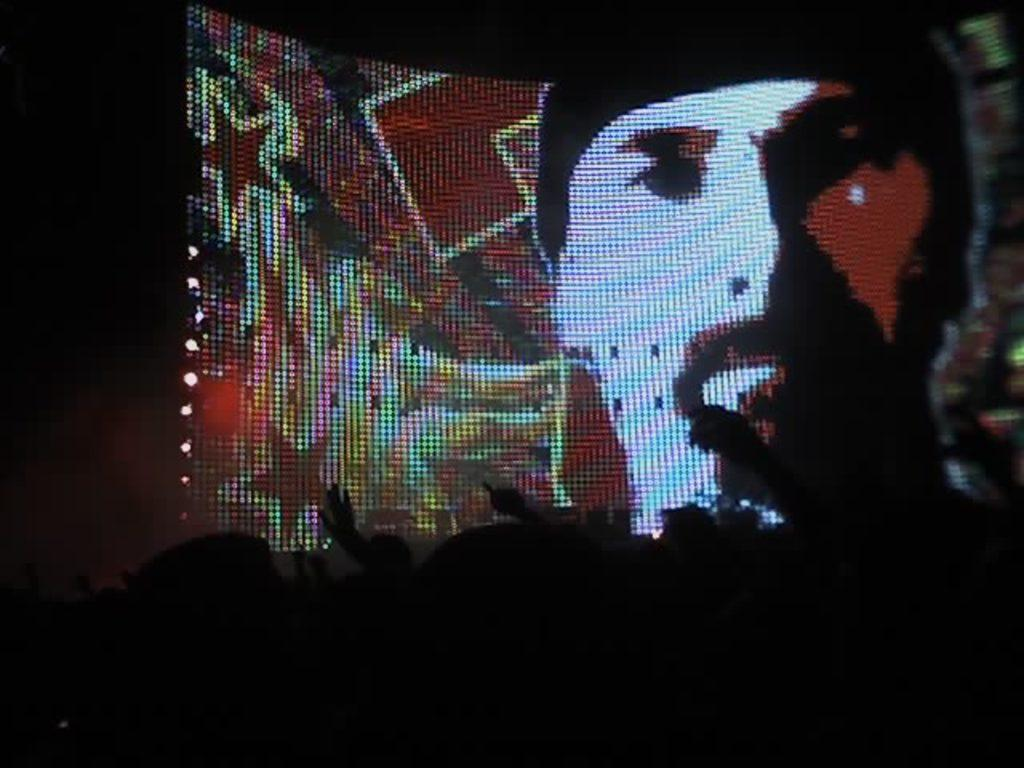What is the overall lighting condition in the image? The image is dark. What can be seen on the screen in the image? A person's face is displayed on the screen. How many grapes are visible on the line in the image? There are no grapes or lines present in the image. What type of step is shown in the image? There is no step visible in the image. 